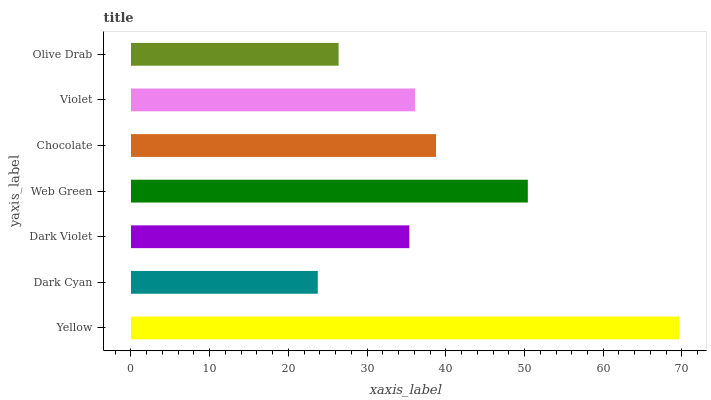Is Dark Cyan the minimum?
Answer yes or no. Yes. Is Yellow the maximum?
Answer yes or no. Yes. Is Dark Violet the minimum?
Answer yes or no. No. Is Dark Violet the maximum?
Answer yes or no. No. Is Dark Violet greater than Dark Cyan?
Answer yes or no. Yes. Is Dark Cyan less than Dark Violet?
Answer yes or no. Yes. Is Dark Cyan greater than Dark Violet?
Answer yes or no. No. Is Dark Violet less than Dark Cyan?
Answer yes or no. No. Is Violet the high median?
Answer yes or no. Yes. Is Violet the low median?
Answer yes or no. Yes. Is Chocolate the high median?
Answer yes or no. No. Is Olive Drab the low median?
Answer yes or no. No. 